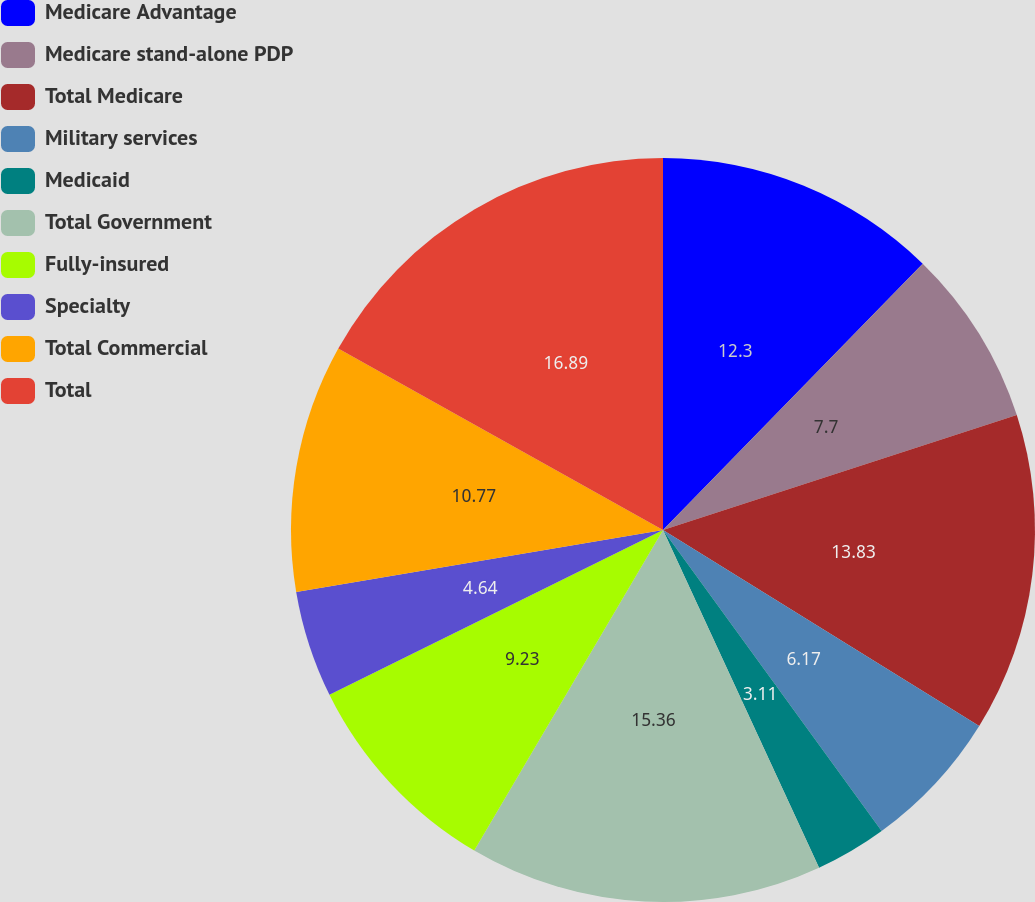Convert chart. <chart><loc_0><loc_0><loc_500><loc_500><pie_chart><fcel>Medicare Advantage<fcel>Medicare stand-alone PDP<fcel>Total Medicare<fcel>Military services<fcel>Medicaid<fcel>Total Government<fcel>Fully-insured<fcel>Specialty<fcel>Total Commercial<fcel>Total<nl><fcel>12.3%<fcel>7.7%<fcel>13.83%<fcel>6.17%<fcel>3.11%<fcel>15.36%<fcel>9.23%<fcel>4.64%<fcel>10.77%<fcel>16.89%<nl></chart> 